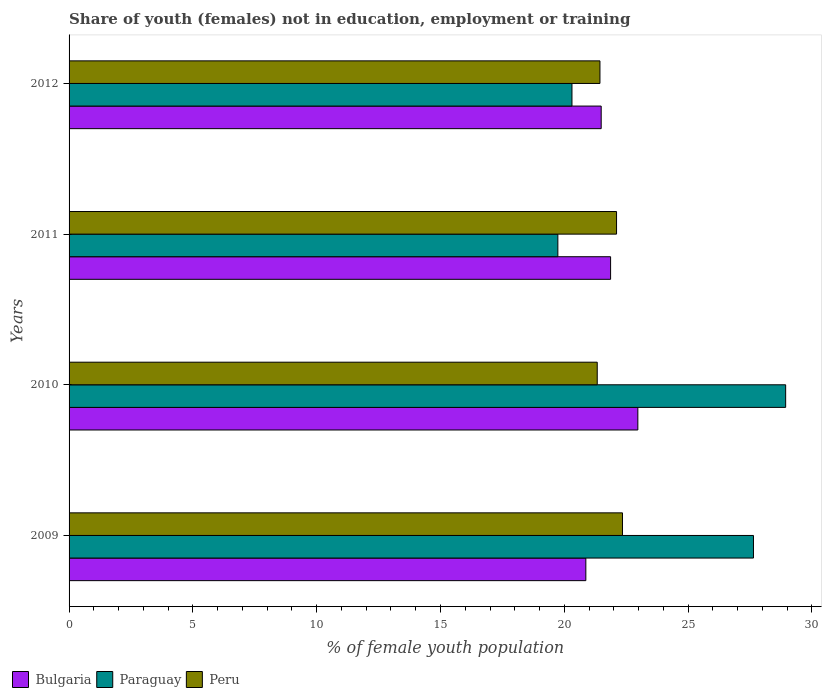Are the number of bars per tick equal to the number of legend labels?
Keep it short and to the point. Yes. How many bars are there on the 1st tick from the top?
Keep it short and to the point. 3. How many bars are there on the 3rd tick from the bottom?
Provide a short and direct response. 3. What is the percentage of unemployed female population in in Paraguay in 2009?
Give a very brief answer. 27.64. Across all years, what is the maximum percentage of unemployed female population in in Bulgaria?
Offer a terse response. 22.97. Across all years, what is the minimum percentage of unemployed female population in in Bulgaria?
Give a very brief answer. 20.87. In which year was the percentage of unemployed female population in in Bulgaria minimum?
Your response must be concise. 2009. What is the total percentage of unemployed female population in in Paraguay in the graph?
Your response must be concise. 96.63. What is the difference between the percentage of unemployed female population in in Peru in 2009 and that in 2012?
Offer a very short reply. 0.91. What is the difference between the percentage of unemployed female population in in Paraguay in 2010 and the percentage of unemployed female population in in Bulgaria in 2009?
Offer a terse response. 8.07. What is the average percentage of unemployed female population in in Peru per year?
Provide a succinct answer. 21.81. In the year 2010, what is the difference between the percentage of unemployed female population in in Peru and percentage of unemployed female population in in Bulgaria?
Your answer should be compact. -1.64. What is the ratio of the percentage of unemployed female population in in Bulgaria in 2009 to that in 2011?
Offer a very short reply. 0.95. Is the percentage of unemployed female population in in Bulgaria in 2010 less than that in 2011?
Give a very brief answer. No. Is the difference between the percentage of unemployed female population in in Peru in 2009 and 2012 greater than the difference between the percentage of unemployed female population in in Bulgaria in 2009 and 2012?
Ensure brevity in your answer.  Yes. What is the difference between the highest and the second highest percentage of unemployed female population in in Bulgaria?
Provide a succinct answer. 1.1. What is the difference between the highest and the lowest percentage of unemployed female population in in Peru?
Keep it short and to the point. 1.02. In how many years, is the percentage of unemployed female population in in Peru greater than the average percentage of unemployed female population in in Peru taken over all years?
Give a very brief answer. 2. What does the 3rd bar from the top in 2012 represents?
Give a very brief answer. Bulgaria. What does the 2nd bar from the bottom in 2011 represents?
Provide a short and direct response. Paraguay. How many bars are there?
Provide a short and direct response. 12. What is the difference between two consecutive major ticks on the X-axis?
Give a very brief answer. 5. Are the values on the major ticks of X-axis written in scientific E-notation?
Keep it short and to the point. No. Does the graph contain any zero values?
Your answer should be compact. No. Does the graph contain grids?
Make the answer very short. No. Where does the legend appear in the graph?
Offer a very short reply. Bottom left. How are the legend labels stacked?
Ensure brevity in your answer.  Horizontal. What is the title of the graph?
Ensure brevity in your answer.  Share of youth (females) not in education, employment or training. What is the label or title of the X-axis?
Make the answer very short. % of female youth population. What is the label or title of the Y-axis?
Give a very brief answer. Years. What is the % of female youth population of Bulgaria in 2009?
Offer a very short reply. 20.87. What is the % of female youth population in Paraguay in 2009?
Make the answer very short. 27.64. What is the % of female youth population of Peru in 2009?
Make the answer very short. 22.35. What is the % of female youth population in Bulgaria in 2010?
Offer a very short reply. 22.97. What is the % of female youth population in Paraguay in 2010?
Provide a succinct answer. 28.94. What is the % of female youth population in Peru in 2010?
Ensure brevity in your answer.  21.33. What is the % of female youth population in Bulgaria in 2011?
Offer a terse response. 21.87. What is the % of female youth population in Paraguay in 2011?
Ensure brevity in your answer.  19.74. What is the % of female youth population in Peru in 2011?
Ensure brevity in your answer.  22.11. What is the % of female youth population of Bulgaria in 2012?
Your response must be concise. 21.49. What is the % of female youth population of Paraguay in 2012?
Your answer should be compact. 20.31. What is the % of female youth population of Peru in 2012?
Ensure brevity in your answer.  21.44. Across all years, what is the maximum % of female youth population in Bulgaria?
Your answer should be compact. 22.97. Across all years, what is the maximum % of female youth population in Paraguay?
Your answer should be compact. 28.94. Across all years, what is the maximum % of female youth population in Peru?
Your response must be concise. 22.35. Across all years, what is the minimum % of female youth population of Bulgaria?
Provide a short and direct response. 20.87. Across all years, what is the minimum % of female youth population in Paraguay?
Offer a very short reply. 19.74. Across all years, what is the minimum % of female youth population in Peru?
Make the answer very short. 21.33. What is the total % of female youth population of Bulgaria in the graph?
Offer a very short reply. 87.2. What is the total % of female youth population in Paraguay in the graph?
Your answer should be very brief. 96.63. What is the total % of female youth population of Peru in the graph?
Provide a short and direct response. 87.23. What is the difference between the % of female youth population of Bulgaria in 2009 and that in 2010?
Offer a very short reply. -2.1. What is the difference between the % of female youth population in Peru in 2009 and that in 2011?
Give a very brief answer. 0.24. What is the difference between the % of female youth population of Bulgaria in 2009 and that in 2012?
Make the answer very short. -0.62. What is the difference between the % of female youth population in Paraguay in 2009 and that in 2012?
Your response must be concise. 7.33. What is the difference between the % of female youth population in Peru in 2009 and that in 2012?
Offer a terse response. 0.91. What is the difference between the % of female youth population in Bulgaria in 2010 and that in 2011?
Give a very brief answer. 1.1. What is the difference between the % of female youth population of Paraguay in 2010 and that in 2011?
Your answer should be very brief. 9.2. What is the difference between the % of female youth population of Peru in 2010 and that in 2011?
Ensure brevity in your answer.  -0.78. What is the difference between the % of female youth population of Bulgaria in 2010 and that in 2012?
Your answer should be compact. 1.48. What is the difference between the % of female youth population of Paraguay in 2010 and that in 2012?
Provide a short and direct response. 8.63. What is the difference between the % of female youth population in Peru in 2010 and that in 2012?
Provide a short and direct response. -0.11. What is the difference between the % of female youth population of Bulgaria in 2011 and that in 2012?
Your answer should be compact. 0.38. What is the difference between the % of female youth population in Paraguay in 2011 and that in 2012?
Your answer should be very brief. -0.57. What is the difference between the % of female youth population in Peru in 2011 and that in 2012?
Your answer should be compact. 0.67. What is the difference between the % of female youth population in Bulgaria in 2009 and the % of female youth population in Paraguay in 2010?
Offer a terse response. -8.07. What is the difference between the % of female youth population of Bulgaria in 2009 and the % of female youth population of Peru in 2010?
Give a very brief answer. -0.46. What is the difference between the % of female youth population of Paraguay in 2009 and the % of female youth population of Peru in 2010?
Make the answer very short. 6.31. What is the difference between the % of female youth population in Bulgaria in 2009 and the % of female youth population in Paraguay in 2011?
Your answer should be very brief. 1.13. What is the difference between the % of female youth population of Bulgaria in 2009 and the % of female youth population of Peru in 2011?
Give a very brief answer. -1.24. What is the difference between the % of female youth population in Paraguay in 2009 and the % of female youth population in Peru in 2011?
Make the answer very short. 5.53. What is the difference between the % of female youth population of Bulgaria in 2009 and the % of female youth population of Paraguay in 2012?
Offer a terse response. 0.56. What is the difference between the % of female youth population of Bulgaria in 2009 and the % of female youth population of Peru in 2012?
Make the answer very short. -0.57. What is the difference between the % of female youth population of Paraguay in 2009 and the % of female youth population of Peru in 2012?
Your answer should be very brief. 6.2. What is the difference between the % of female youth population of Bulgaria in 2010 and the % of female youth population of Paraguay in 2011?
Offer a terse response. 3.23. What is the difference between the % of female youth population of Bulgaria in 2010 and the % of female youth population of Peru in 2011?
Provide a succinct answer. 0.86. What is the difference between the % of female youth population in Paraguay in 2010 and the % of female youth population in Peru in 2011?
Your answer should be very brief. 6.83. What is the difference between the % of female youth population of Bulgaria in 2010 and the % of female youth population of Paraguay in 2012?
Give a very brief answer. 2.66. What is the difference between the % of female youth population of Bulgaria in 2010 and the % of female youth population of Peru in 2012?
Your response must be concise. 1.53. What is the difference between the % of female youth population of Paraguay in 2010 and the % of female youth population of Peru in 2012?
Your response must be concise. 7.5. What is the difference between the % of female youth population in Bulgaria in 2011 and the % of female youth population in Paraguay in 2012?
Ensure brevity in your answer.  1.56. What is the difference between the % of female youth population of Bulgaria in 2011 and the % of female youth population of Peru in 2012?
Ensure brevity in your answer.  0.43. What is the average % of female youth population in Bulgaria per year?
Your answer should be compact. 21.8. What is the average % of female youth population in Paraguay per year?
Give a very brief answer. 24.16. What is the average % of female youth population in Peru per year?
Offer a very short reply. 21.81. In the year 2009, what is the difference between the % of female youth population of Bulgaria and % of female youth population of Paraguay?
Offer a terse response. -6.77. In the year 2009, what is the difference between the % of female youth population of Bulgaria and % of female youth population of Peru?
Provide a succinct answer. -1.48. In the year 2009, what is the difference between the % of female youth population in Paraguay and % of female youth population in Peru?
Your response must be concise. 5.29. In the year 2010, what is the difference between the % of female youth population in Bulgaria and % of female youth population in Paraguay?
Keep it short and to the point. -5.97. In the year 2010, what is the difference between the % of female youth population of Bulgaria and % of female youth population of Peru?
Ensure brevity in your answer.  1.64. In the year 2010, what is the difference between the % of female youth population of Paraguay and % of female youth population of Peru?
Give a very brief answer. 7.61. In the year 2011, what is the difference between the % of female youth population in Bulgaria and % of female youth population in Paraguay?
Keep it short and to the point. 2.13. In the year 2011, what is the difference between the % of female youth population of Bulgaria and % of female youth population of Peru?
Your answer should be compact. -0.24. In the year 2011, what is the difference between the % of female youth population in Paraguay and % of female youth population in Peru?
Your response must be concise. -2.37. In the year 2012, what is the difference between the % of female youth population of Bulgaria and % of female youth population of Paraguay?
Make the answer very short. 1.18. In the year 2012, what is the difference between the % of female youth population in Bulgaria and % of female youth population in Peru?
Ensure brevity in your answer.  0.05. In the year 2012, what is the difference between the % of female youth population in Paraguay and % of female youth population in Peru?
Provide a succinct answer. -1.13. What is the ratio of the % of female youth population in Bulgaria in 2009 to that in 2010?
Offer a terse response. 0.91. What is the ratio of the % of female youth population in Paraguay in 2009 to that in 2010?
Offer a very short reply. 0.96. What is the ratio of the % of female youth population in Peru in 2009 to that in 2010?
Your answer should be very brief. 1.05. What is the ratio of the % of female youth population in Bulgaria in 2009 to that in 2011?
Provide a succinct answer. 0.95. What is the ratio of the % of female youth population in Paraguay in 2009 to that in 2011?
Provide a succinct answer. 1.4. What is the ratio of the % of female youth population of Peru in 2009 to that in 2011?
Keep it short and to the point. 1.01. What is the ratio of the % of female youth population in Bulgaria in 2009 to that in 2012?
Offer a very short reply. 0.97. What is the ratio of the % of female youth population of Paraguay in 2009 to that in 2012?
Keep it short and to the point. 1.36. What is the ratio of the % of female youth population of Peru in 2009 to that in 2012?
Keep it short and to the point. 1.04. What is the ratio of the % of female youth population of Bulgaria in 2010 to that in 2011?
Provide a succinct answer. 1.05. What is the ratio of the % of female youth population in Paraguay in 2010 to that in 2011?
Offer a very short reply. 1.47. What is the ratio of the % of female youth population of Peru in 2010 to that in 2011?
Ensure brevity in your answer.  0.96. What is the ratio of the % of female youth population in Bulgaria in 2010 to that in 2012?
Ensure brevity in your answer.  1.07. What is the ratio of the % of female youth population of Paraguay in 2010 to that in 2012?
Offer a terse response. 1.42. What is the ratio of the % of female youth population in Peru in 2010 to that in 2012?
Your response must be concise. 0.99. What is the ratio of the % of female youth population in Bulgaria in 2011 to that in 2012?
Give a very brief answer. 1.02. What is the ratio of the % of female youth population of Paraguay in 2011 to that in 2012?
Keep it short and to the point. 0.97. What is the ratio of the % of female youth population of Peru in 2011 to that in 2012?
Keep it short and to the point. 1.03. What is the difference between the highest and the second highest % of female youth population of Bulgaria?
Ensure brevity in your answer.  1.1. What is the difference between the highest and the second highest % of female youth population of Paraguay?
Keep it short and to the point. 1.3. What is the difference between the highest and the second highest % of female youth population in Peru?
Make the answer very short. 0.24. What is the difference between the highest and the lowest % of female youth population in Peru?
Make the answer very short. 1.02. 